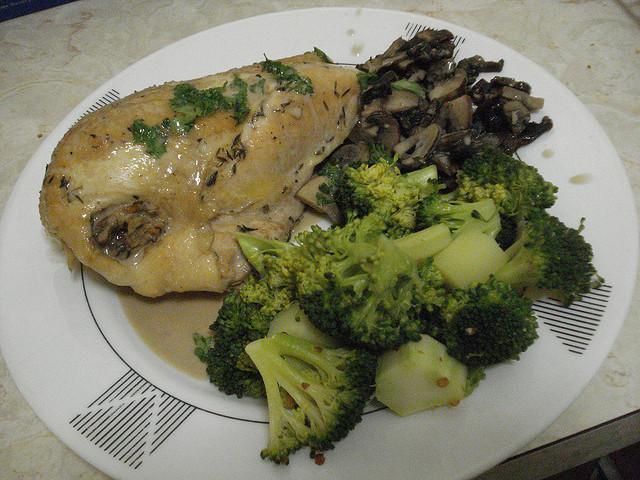How many broccolis are there?
Give a very brief answer. 6. 